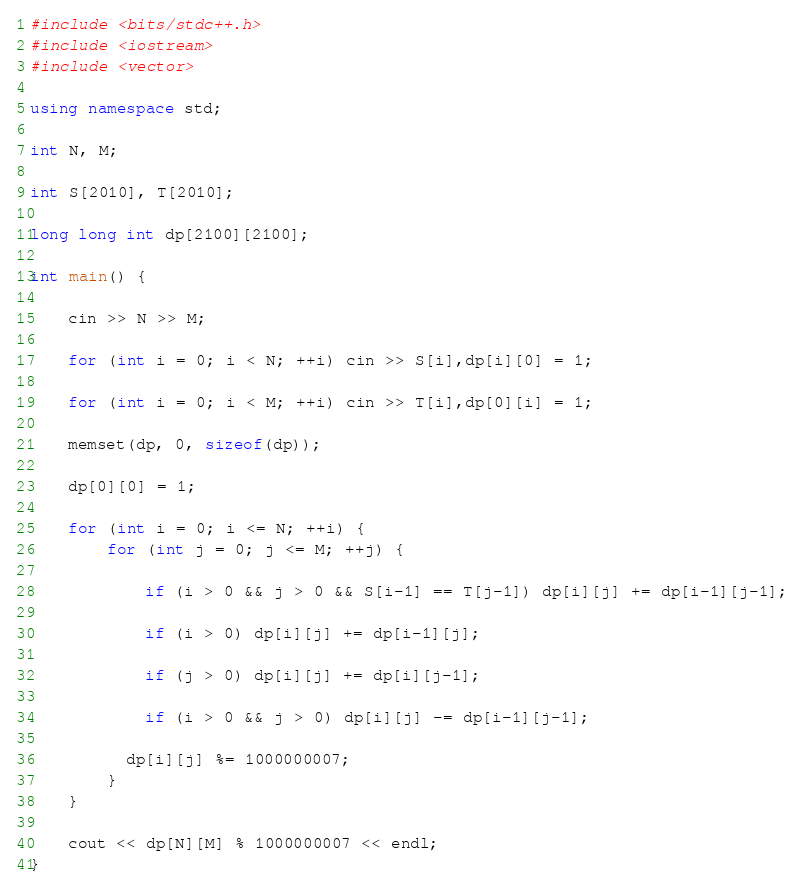Convert code to text. <code><loc_0><loc_0><loc_500><loc_500><_C++_>#include <bits/stdc++.h>
#include <iostream>
#include <vector>

using namespace std;

int N, M;

int S[2010], T[2010];

long long int dp[2100][2100];
 
int main() {
  
    cin >> N >> M;
  
    for (int i = 0; i < N; ++i) cin >> S[i],dp[i][0] = 1;
  
    for (int i = 0; i < M; ++i) cin >> T[i],dp[0][i] = 1;
 
    memset(dp, 0, sizeof(dp));
  
    dp[0][0] = 1;
  
    for (int i = 0; i <= N; ++i) {
        for (int j = 0; j <= M; ++j) {
          
            if (i > 0 && j > 0 && S[i-1] == T[j-1]) dp[i][j] += dp[i-1][j-1];
                              
            if (i > 0) dp[i][j] += dp[i-1][j];
                 
            if (j > 0) dp[i][j] += dp[i][j-1];        
          
            if (i > 0 && j > 0) dp[i][j] -= dp[i-1][j-1]; 
          
          dp[i][j] %= 1000000007;
        }
    }
  
    cout << dp[N][M] % 1000000007 << endl;
}
</code> 